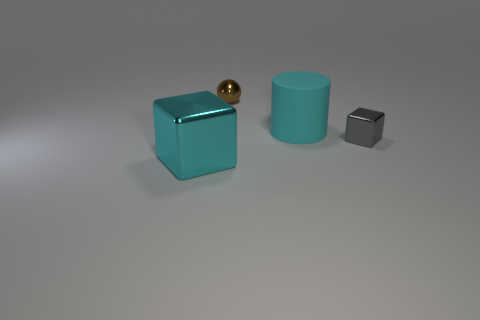Subtract all cylinders. How many objects are left? 3 Subtract 1 cylinders. How many cylinders are left? 0 Add 3 metal blocks. How many objects exist? 7 Subtract 0 purple cylinders. How many objects are left? 4 Subtract all blue blocks. Subtract all brown cylinders. How many blocks are left? 2 Subtract all blue balls. How many cyan cubes are left? 1 Subtract all small brown spheres. Subtract all shiny blocks. How many objects are left? 1 Add 4 large cyan shiny objects. How many large cyan shiny objects are left? 5 Add 4 large shiny things. How many large shiny things exist? 5 